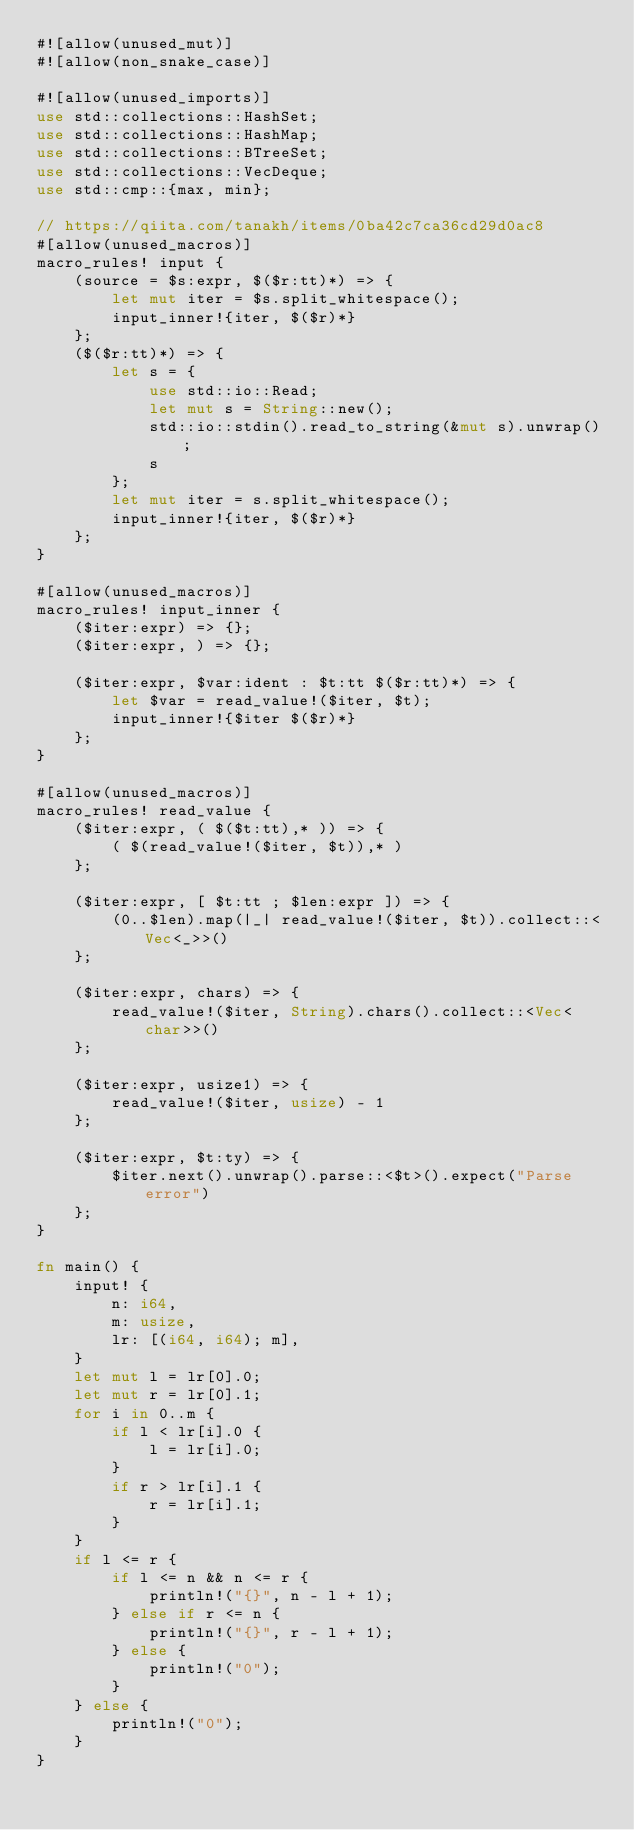<code> <loc_0><loc_0><loc_500><loc_500><_Rust_>#![allow(unused_mut)]
#![allow(non_snake_case)]

#![allow(unused_imports)]
use std::collections::HashSet;
use std::collections::HashMap;
use std::collections::BTreeSet;
use std::collections::VecDeque;
use std::cmp::{max, min};

// https://qiita.com/tanakh/items/0ba42c7ca36cd29d0ac8
#[allow(unused_macros)]
macro_rules! input {
    (source = $s:expr, $($r:tt)*) => {
        let mut iter = $s.split_whitespace();
        input_inner!{iter, $($r)*}
    };
    ($($r:tt)*) => {
        let s = {
            use std::io::Read;
            let mut s = String::new();
            std::io::stdin().read_to_string(&mut s).unwrap();
            s
        };
        let mut iter = s.split_whitespace();
        input_inner!{iter, $($r)*}
    };
}

#[allow(unused_macros)]
macro_rules! input_inner {
    ($iter:expr) => {};
    ($iter:expr, ) => {};

    ($iter:expr, $var:ident : $t:tt $($r:tt)*) => {
        let $var = read_value!($iter, $t);
        input_inner!{$iter $($r)*}
    };
}

#[allow(unused_macros)]
macro_rules! read_value {
    ($iter:expr, ( $($t:tt),* )) => {
        ( $(read_value!($iter, $t)),* )
    };

    ($iter:expr, [ $t:tt ; $len:expr ]) => {
        (0..$len).map(|_| read_value!($iter, $t)).collect::<Vec<_>>()
    };

    ($iter:expr, chars) => {
        read_value!($iter, String).chars().collect::<Vec<char>>()
    };

    ($iter:expr, usize1) => {
        read_value!($iter, usize) - 1
    };

    ($iter:expr, $t:ty) => {
        $iter.next().unwrap().parse::<$t>().expect("Parse error")
    };
}

fn main() {
    input! {
        n: i64,
        m: usize,
        lr: [(i64, i64); m],
    }
    let mut l = lr[0].0;
    let mut r = lr[0].1;
    for i in 0..m {
        if l < lr[i].0 {
            l = lr[i].0;
        }
        if r > lr[i].1 {
            r = lr[i].1;
        }
    }
    if l <= r {
        if l <= n && n <= r {
            println!("{}", n - l + 1);
        } else if r <= n {
            println!("{}", r - l + 1);
        } else {
            println!("0");
        }
    } else {
        println!("0");
    }
}</code> 